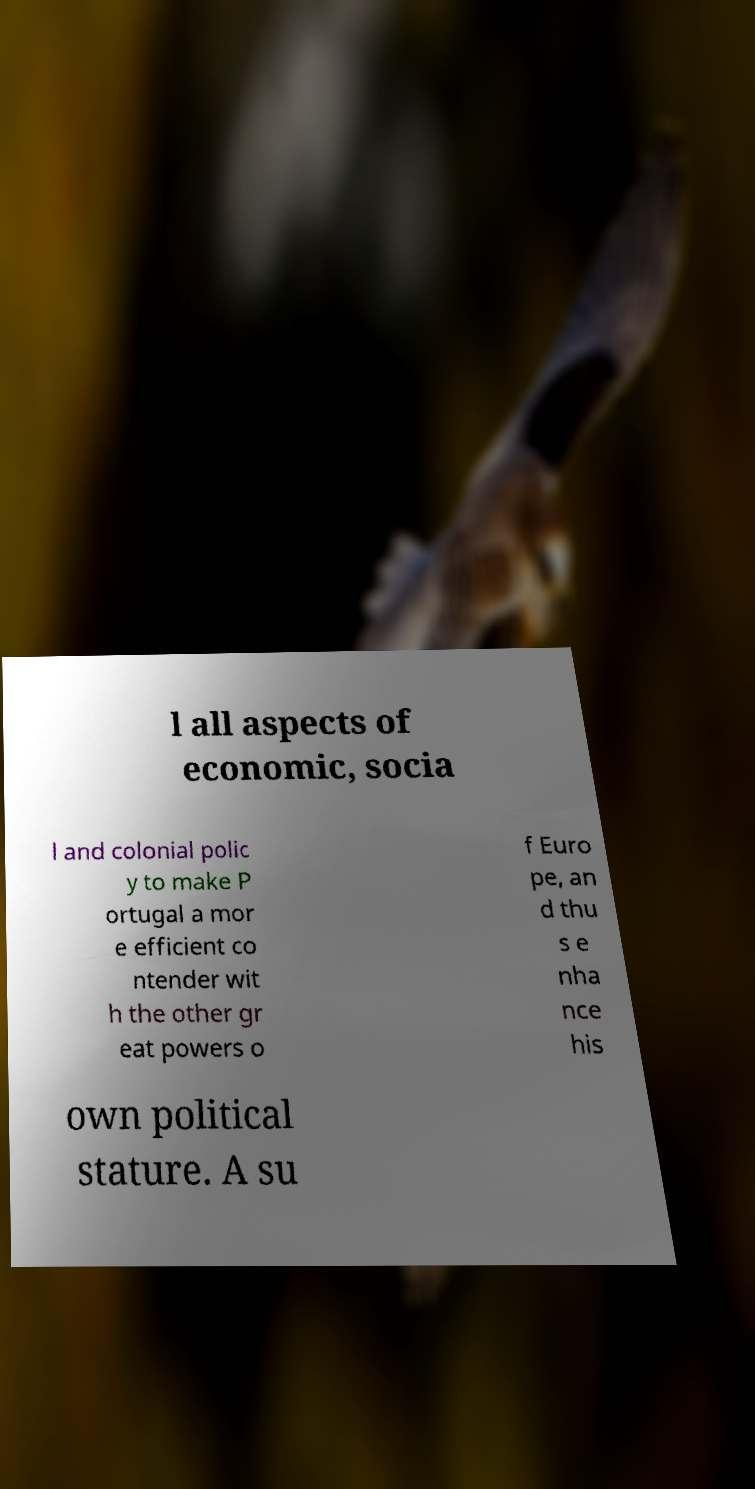Please read and relay the text visible in this image. What does it say? l all aspects of economic, socia l and colonial polic y to make P ortugal a mor e efficient co ntender wit h the other gr eat powers o f Euro pe, an d thu s e nha nce his own political stature. A su 